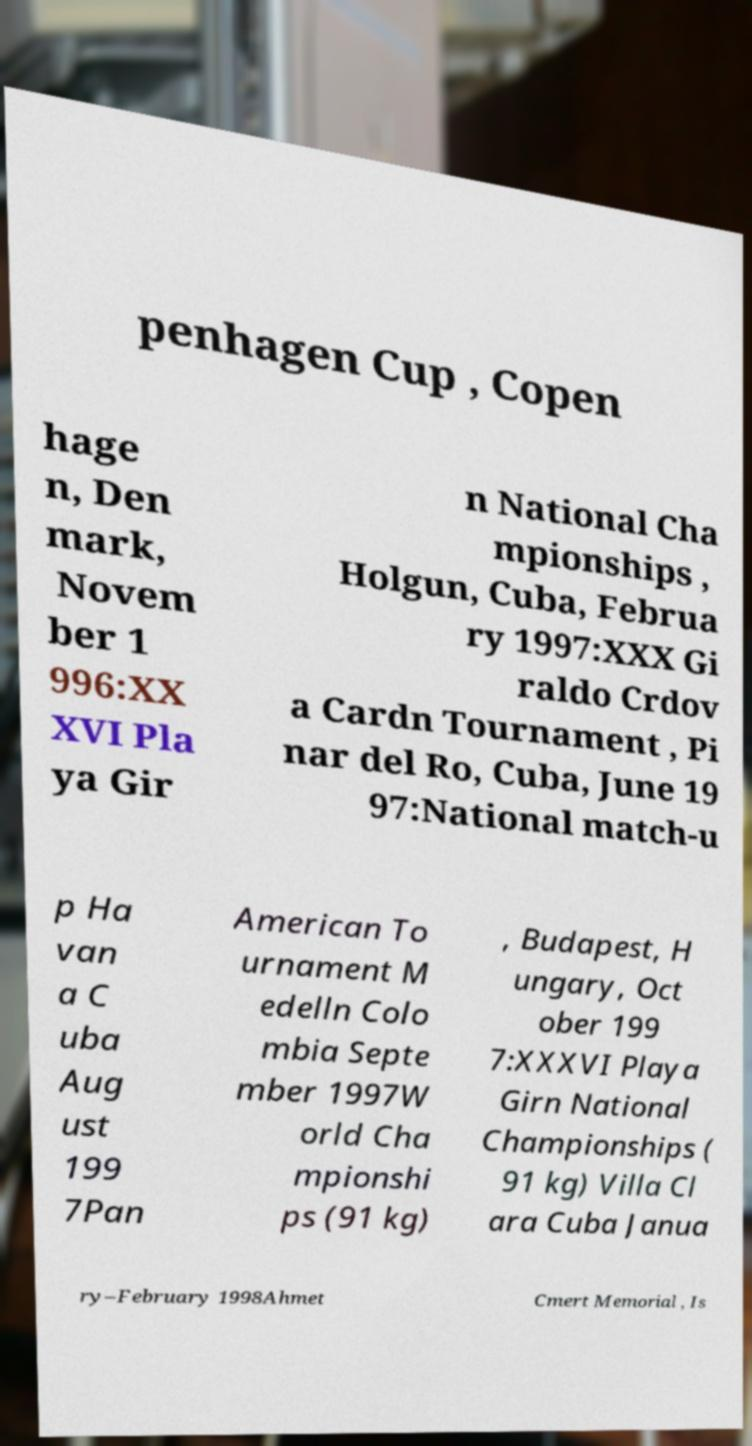For documentation purposes, I need the text within this image transcribed. Could you provide that? penhagen Cup , Copen hage n, Den mark, Novem ber 1 996:XX XVI Pla ya Gir n National Cha mpionships , Holgun, Cuba, Februa ry 1997:XXX Gi raldo Crdov a Cardn Tournament , Pi nar del Ro, Cuba, June 19 97:National match-u p Ha van a C uba Aug ust 199 7Pan American To urnament M edelln Colo mbia Septe mber 1997W orld Cha mpionshi ps (91 kg) , Budapest, H ungary, Oct ober 199 7:XXXVI Playa Girn National Championships ( 91 kg) Villa Cl ara Cuba Janua ry–February 1998Ahmet Cmert Memorial , Is 